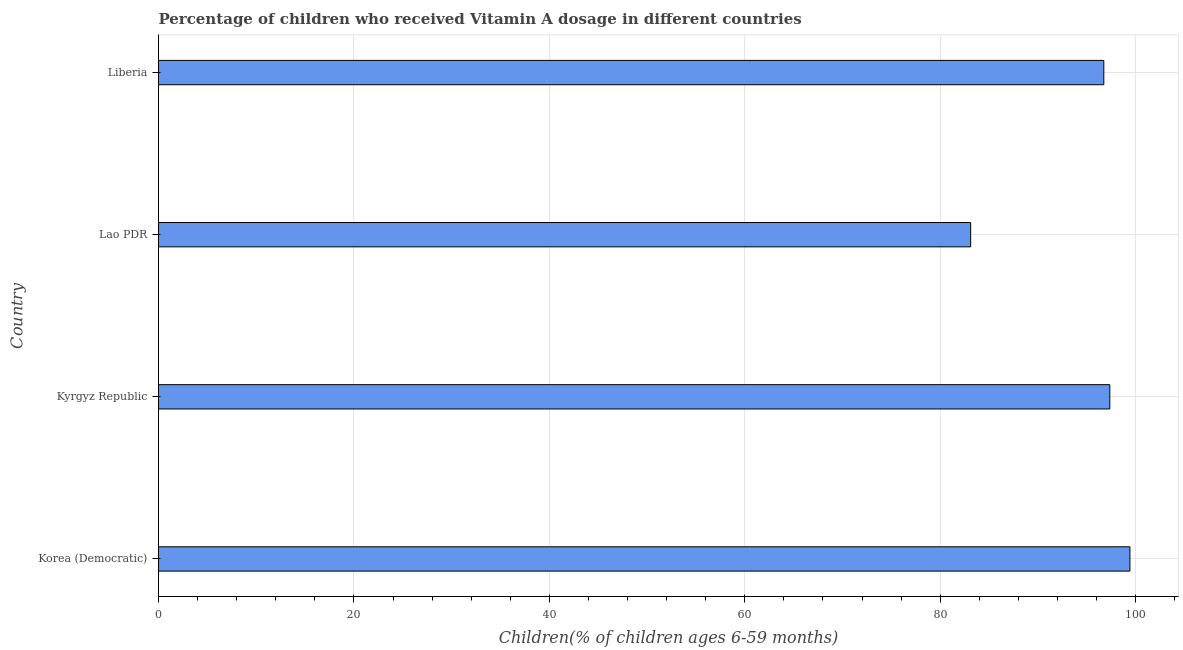Does the graph contain any zero values?
Make the answer very short. No. Does the graph contain grids?
Make the answer very short. Yes. What is the title of the graph?
Keep it short and to the point. Percentage of children who received Vitamin A dosage in different countries. What is the label or title of the X-axis?
Your answer should be compact. Children(% of children ages 6-59 months). What is the vitamin a supplementation coverage rate in Lao PDR?
Your answer should be very brief. 83.12. Across all countries, what is the maximum vitamin a supplementation coverage rate?
Offer a very short reply. 99.41. Across all countries, what is the minimum vitamin a supplementation coverage rate?
Offer a very short reply. 83.12. In which country was the vitamin a supplementation coverage rate maximum?
Offer a very short reply. Korea (Democratic). In which country was the vitamin a supplementation coverage rate minimum?
Your answer should be compact. Lao PDR. What is the sum of the vitamin a supplementation coverage rate?
Provide a succinct answer. 376.62. What is the difference between the vitamin a supplementation coverage rate in Korea (Democratic) and Kyrgyz Republic?
Give a very brief answer. 2.06. What is the average vitamin a supplementation coverage rate per country?
Your response must be concise. 94.16. What is the median vitamin a supplementation coverage rate?
Give a very brief answer. 97.05. What is the ratio of the vitamin a supplementation coverage rate in Korea (Democratic) to that in Lao PDR?
Ensure brevity in your answer.  1.2. Is the vitamin a supplementation coverage rate in Korea (Democratic) less than that in Lao PDR?
Offer a terse response. No. What is the difference between the highest and the second highest vitamin a supplementation coverage rate?
Offer a terse response. 2.06. What is the difference between the highest and the lowest vitamin a supplementation coverage rate?
Offer a very short reply. 16.3. Are all the bars in the graph horizontal?
Your response must be concise. Yes. Are the values on the major ticks of X-axis written in scientific E-notation?
Offer a very short reply. No. What is the Children(% of children ages 6-59 months) in Korea (Democratic)?
Provide a short and direct response. 99.41. What is the Children(% of children ages 6-59 months) of Kyrgyz Republic?
Your response must be concise. 97.35. What is the Children(% of children ages 6-59 months) in Lao PDR?
Your answer should be compact. 83.12. What is the Children(% of children ages 6-59 months) of Liberia?
Your answer should be compact. 96.74. What is the difference between the Children(% of children ages 6-59 months) in Korea (Democratic) and Kyrgyz Republic?
Your answer should be very brief. 2.06. What is the difference between the Children(% of children ages 6-59 months) in Korea (Democratic) and Lao PDR?
Your answer should be very brief. 16.3. What is the difference between the Children(% of children ages 6-59 months) in Korea (Democratic) and Liberia?
Your answer should be very brief. 2.67. What is the difference between the Children(% of children ages 6-59 months) in Kyrgyz Republic and Lao PDR?
Keep it short and to the point. 14.24. What is the difference between the Children(% of children ages 6-59 months) in Kyrgyz Republic and Liberia?
Provide a succinct answer. 0.61. What is the difference between the Children(% of children ages 6-59 months) in Lao PDR and Liberia?
Offer a terse response. -13.63. What is the ratio of the Children(% of children ages 6-59 months) in Korea (Democratic) to that in Lao PDR?
Keep it short and to the point. 1.2. What is the ratio of the Children(% of children ages 6-59 months) in Korea (Democratic) to that in Liberia?
Ensure brevity in your answer.  1.03. What is the ratio of the Children(% of children ages 6-59 months) in Kyrgyz Republic to that in Lao PDR?
Your answer should be very brief. 1.17. What is the ratio of the Children(% of children ages 6-59 months) in Kyrgyz Republic to that in Liberia?
Offer a terse response. 1.01. What is the ratio of the Children(% of children ages 6-59 months) in Lao PDR to that in Liberia?
Provide a succinct answer. 0.86. 